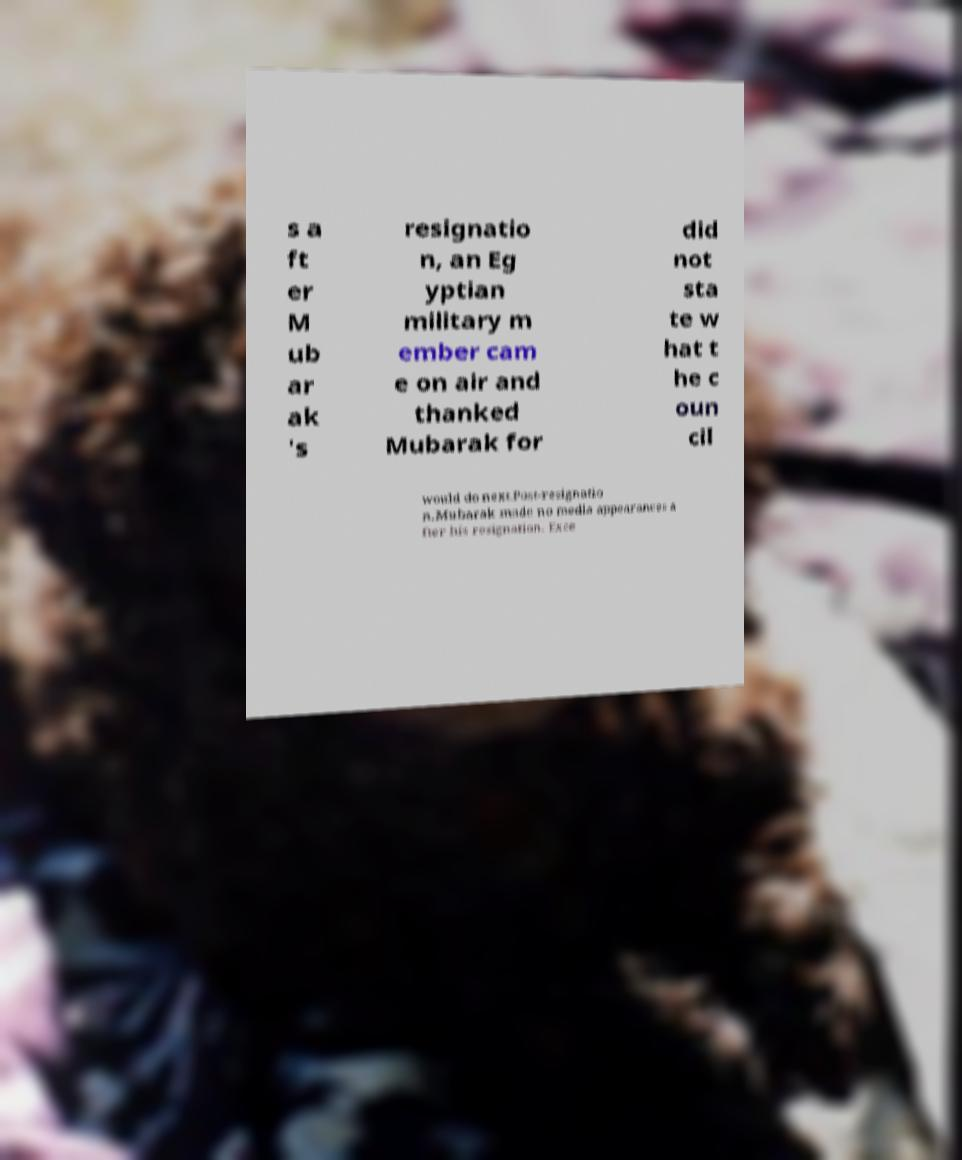I need the written content from this picture converted into text. Can you do that? s a ft er M ub ar ak 's resignatio n, an Eg yptian military m ember cam e on air and thanked Mubarak for did not sta te w hat t he c oun cil would do next.Post-resignatio n.Mubarak made no media appearances a fter his resignation. Exce 